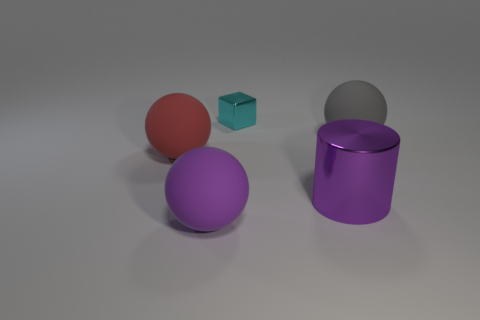Reflect on the aesthetic or mood conveyed by the arrangement of objects. The arrangement of objects against a neutral background creates a clean and minimalist aesthetic. The use of soft lighting and a variety of colors gives the scene a calm and balanced mood, suggesting a sense of harmony and order among the different shapes and finishes. 